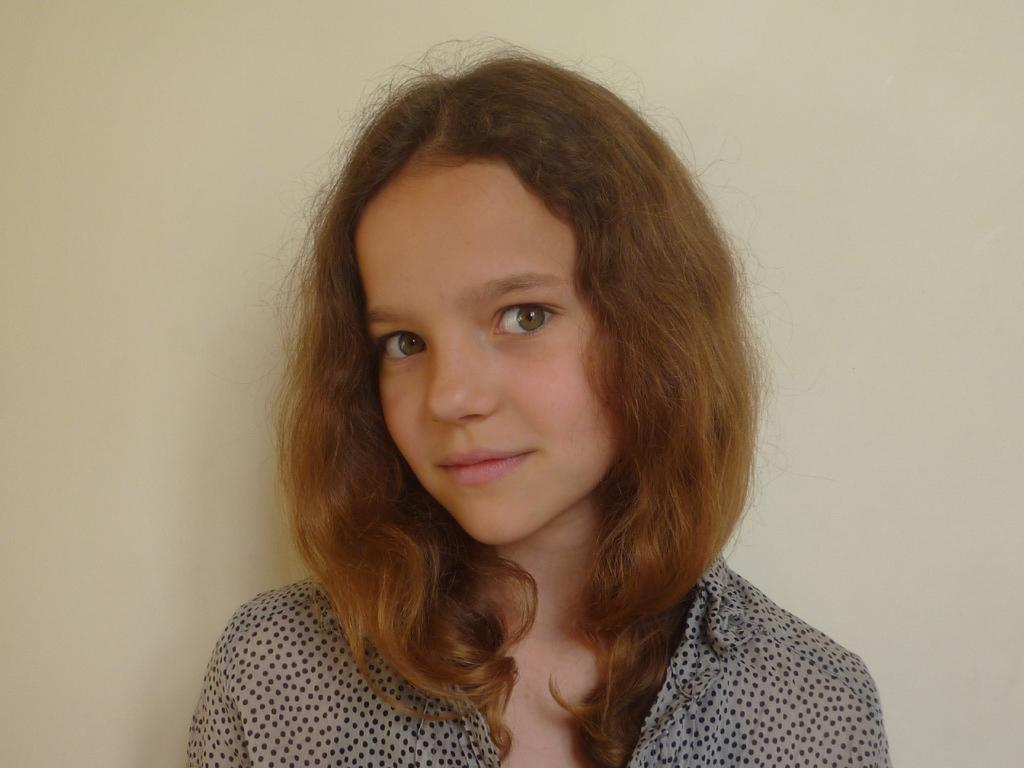Who is the main subject in the image? There is a girl in the center of the image. What is the girl doing in the image? The girl is smiling. What can be seen in the background of the image? There is a wall in the background of the image. What color is the steam coming out of the girl's ears in the image? There is no steam coming out of the girl's ears in the image; she is simply smiling. 